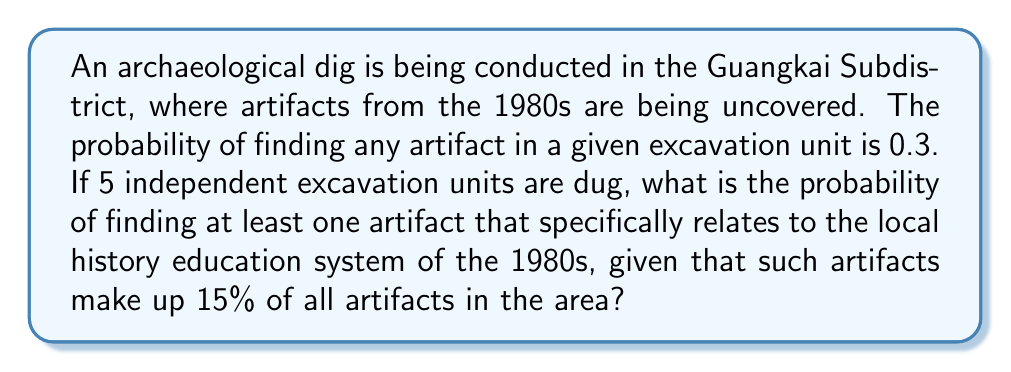Provide a solution to this math problem. Let's approach this step-by-step:

1) First, we need to find the probability of finding a history education-related artifact in a single excavation unit.

   P(history education artifact) = P(any artifact) × P(history education | artifact)
   $$ 0.3 \times 0.15 = 0.045 $$

2) Now, we need to find the probability of not finding a history education artifact in a single unit:
   $$ 1 - 0.045 = 0.955 $$

3) For 5 independent excavation units, the probability of not finding any history education artifacts is:
   $$ (0.955)^5 \approx 0.7969 $$

4) Therefore, the probability of finding at least one history education artifact is:
   $$ 1 - (0.955)^5 \approx 1 - 0.7969 = 0.2031 $$

5) Converting to a percentage:
   $$ 0.2031 \times 100\% \approx 20.31\% $$
Answer: 20.31% 